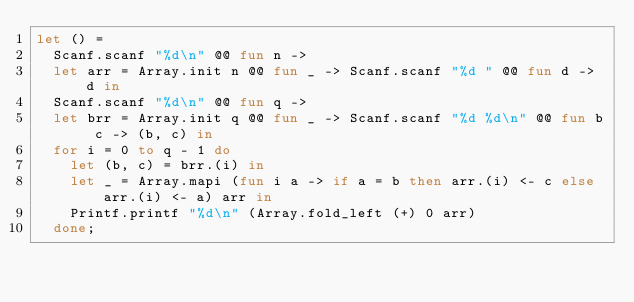<code> <loc_0><loc_0><loc_500><loc_500><_OCaml_>let () =
  Scanf.scanf "%d\n" @@ fun n ->
  let arr = Array.init n @@ fun _ -> Scanf.scanf "%d " @@ fun d -> d in
  Scanf.scanf "%d\n" @@ fun q ->
  let brr = Array.init q @@ fun _ -> Scanf.scanf "%d %d\n" @@ fun b c -> (b, c) in
  for i = 0 to q - 1 do
    let (b, c) = brr.(i) in
    let _ = Array.mapi (fun i a -> if a = b then arr.(i) <- c else arr.(i) <- a) arr in
    Printf.printf "%d\n" (Array.fold_left (+) 0 arr)
  done;</code> 